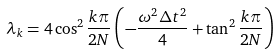Convert formula to latex. <formula><loc_0><loc_0><loc_500><loc_500>\lambda _ { k } = 4 \cos ^ { 2 } \frac { k \pi } { 2 N } \left ( - \frac { \omega ^ { 2 } \Delta t ^ { 2 } } 4 + \tan ^ { 2 } \frac { k \pi } { 2 N } \right )</formula> 